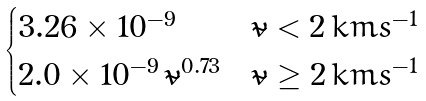Convert formula to latex. <formula><loc_0><loc_0><loc_500><loc_500>\begin{cases} 3 . 2 6 \times 1 0 ^ { - 9 } & \tilde { v } < 2 \, k m s ^ { - 1 } \\ 2 . 0 \times 1 0 ^ { - 9 } \, \tilde { v } ^ { 0 . 7 3 } & \tilde { v } \geq 2 \, k m s ^ { - 1 } \end{cases}</formula> 